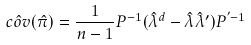<formula> <loc_0><loc_0><loc_500><loc_500>\hat { c o v } ( \hat { \pi } ) = \frac { 1 } { n - 1 } P ^ { - 1 } ( \hat { \lambda } ^ { d } - \hat { \lambda } \hat { \lambda } ^ { \prime } ) P ^ { ^ { \prime } - 1 }</formula> 